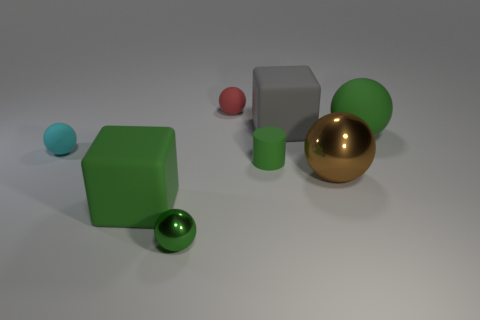There is a metallic object on the right side of the red object; what is its color?
Provide a short and direct response. Brown. Are there any gray blocks in front of the large green matte thing left of the red matte sphere?
Keep it short and to the point. No. Is the number of large purple shiny objects less than the number of matte cylinders?
Make the answer very short. Yes. What is the material of the big green object that is to the left of the big matte thing to the right of the large gray block?
Ensure brevity in your answer.  Rubber. Do the green block and the red thing have the same size?
Give a very brief answer. No. How many objects are either green things or tiny purple spheres?
Your response must be concise. 4. There is a green rubber object that is on the left side of the large gray matte thing and right of the tiny red object; how big is it?
Give a very brief answer. Small. Is the number of tiny green cylinders that are behind the tiny cylinder less than the number of gray blocks?
Your answer should be compact. Yes. What shape is the large object that is the same material as the small green sphere?
Keep it short and to the point. Sphere. Is the shape of the big matte object that is in front of the cyan thing the same as the big green matte object that is right of the cylinder?
Offer a terse response. No. 